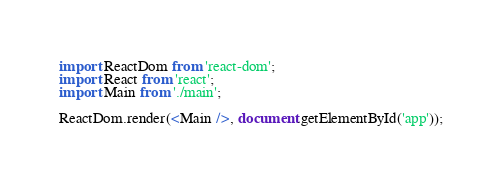<code> <loc_0><loc_0><loc_500><loc_500><_JavaScript_>import ReactDom from 'react-dom';
import React from 'react';
import Main from './main';

ReactDom.render(<Main />, document.getElementById('app'));
</code> 